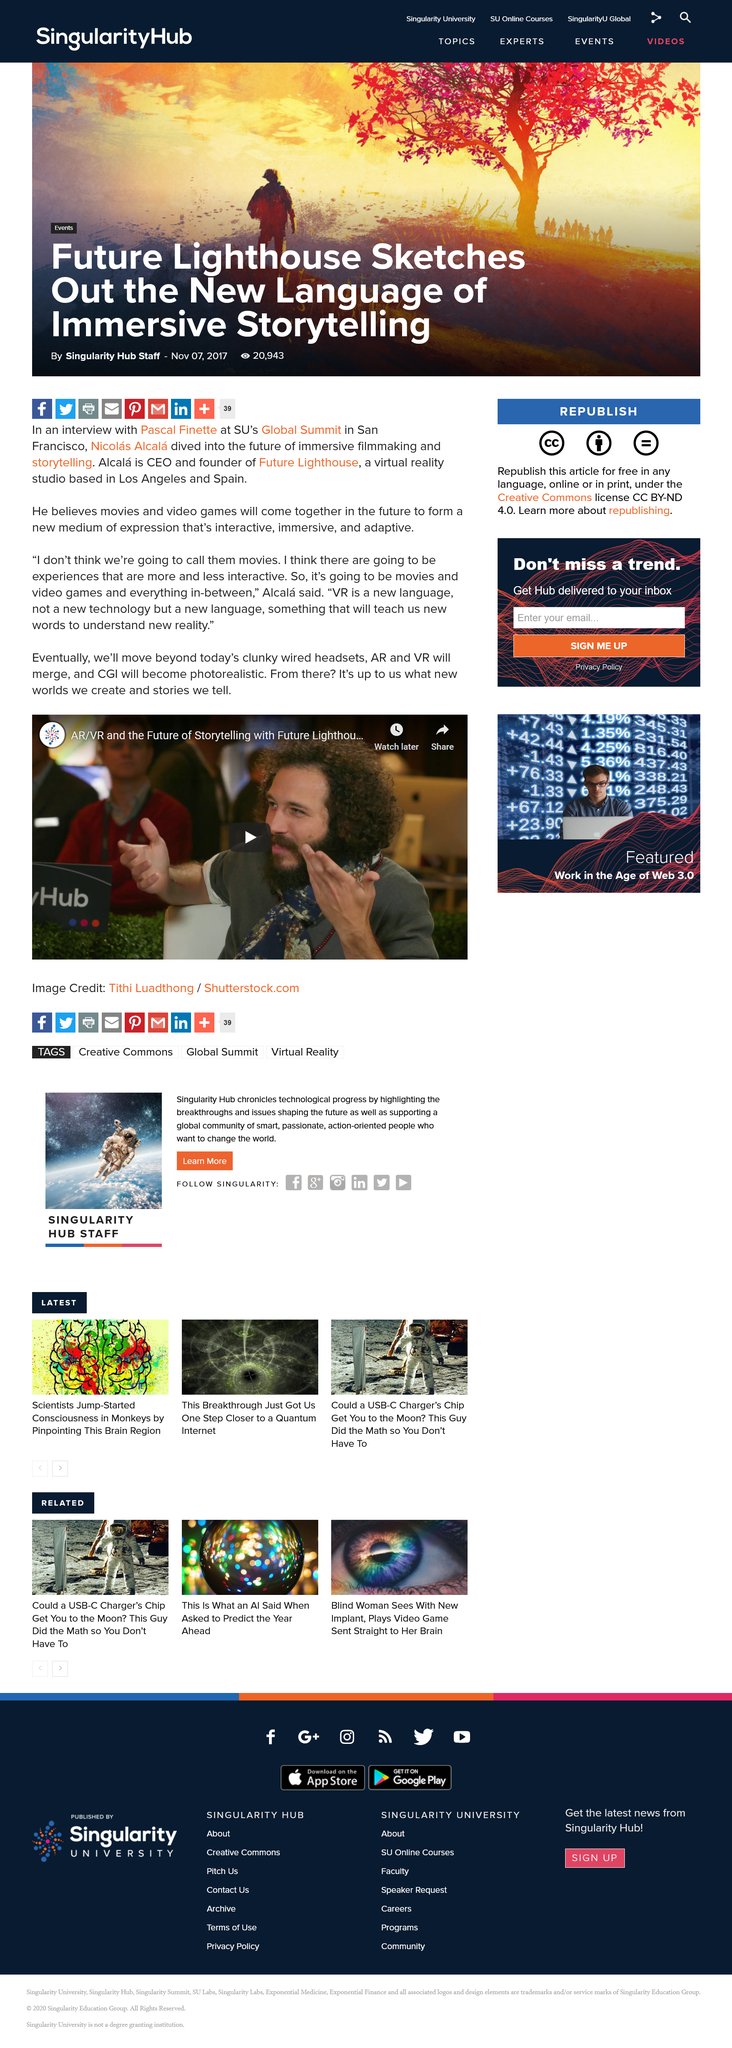List a handful of essential elements in this visual. CGI will become increasingly photorealistic, allowing for more realistic and immersive digital experiences. Virtual reality is a new language that enables us to learn and understand new concepts and realities. What is a new language according to Alcala? Virtual Reality. 